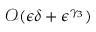<formula> <loc_0><loc_0><loc_500><loc_500>\mathcal { O } ( \epsilon \delta + \epsilon ^ { \gamma _ { 3 } } )</formula> 